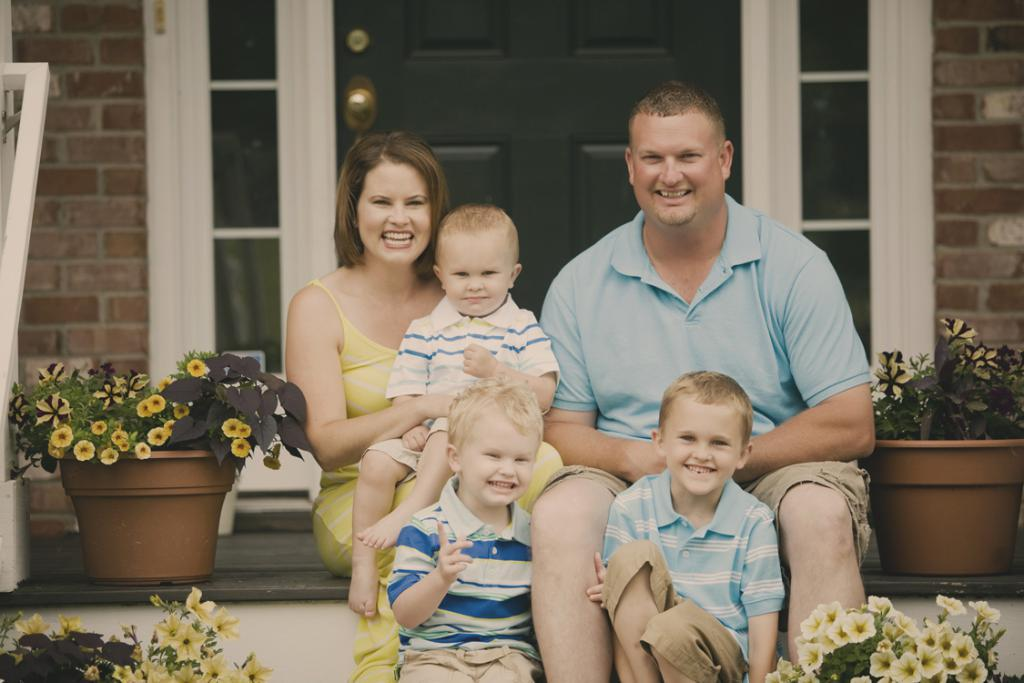How many people are present in the image? There are five people in the image. What is the facial expression of the people in the image? The people are smiling. What type of plants can be seen in the image? There are house plants with flowers in the image. What architectural features are visible in the background of the image? There is a door and a wall in the background of the image. What historical event is being discussed by the people in the image? There is no indication of a historical event being discussed in the image; the people are simply smiling. What point is being made by the person on the left in the image? There is no specific point being made by any person in the image; they are all smiling and no conversation is depicted. 